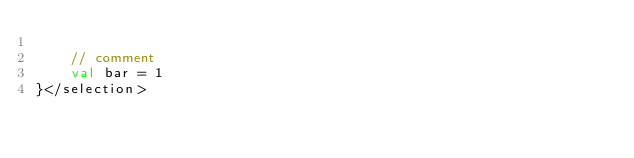<code> <loc_0><loc_0><loc_500><loc_500><_Kotlin_>
    // comment
    val bar = 1
}</selection></code> 